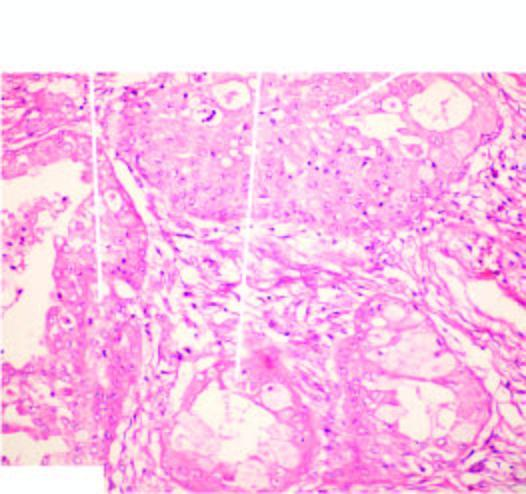what does the tumour show?
Answer the question using a single word or phrase. Combination of mucinous 